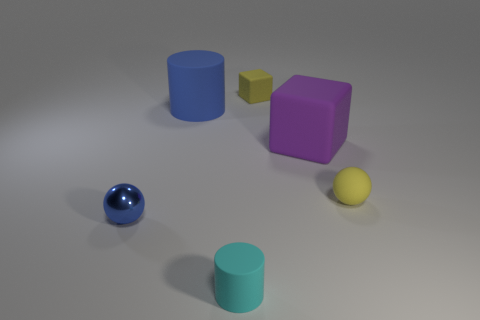Add 4 large gray shiny blocks. How many objects exist? 10 Subtract all tiny yellow things. Subtract all purple objects. How many objects are left? 3 Add 5 purple blocks. How many purple blocks are left? 6 Add 1 large purple objects. How many large purple objects exist? 2 Subtract 0 red cylinders. How many objects are left? 6 